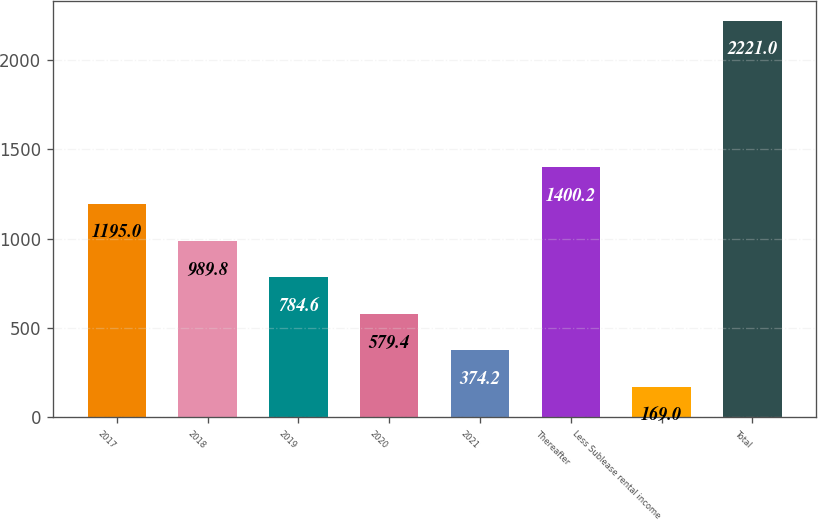Convert chart. <chart><loc_0><loc_0><loc_500><loc_500><bar_chart><fcel>2017<fcel>2018<fcel>2019<fcel>2020<fcel>2021<fcel>Thereafter<fcel>Less Sublease rental income<fcel>Total<nl><fcel>1195<fcel>989.8<fcel>784.6<fcel>579.4<fcel>374.2<fcel>1400.2<fcel>169<fcel>2221<nl></chart> 